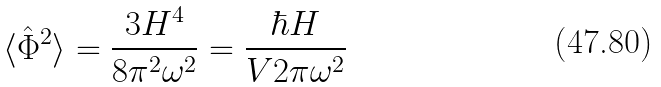<formula> <loc_0><loc_0><loc_500><loc_500>\langle { \hat { \Phi } } ^ { 2 } \rangle = \frac { 3 H ^ { 4 } } { 8 \pi ^ { 2 } \omega ^ { 2 } } = \frac { \hbar { H } } { V 2 \pi \omega ^ { 2 } }</formula> 